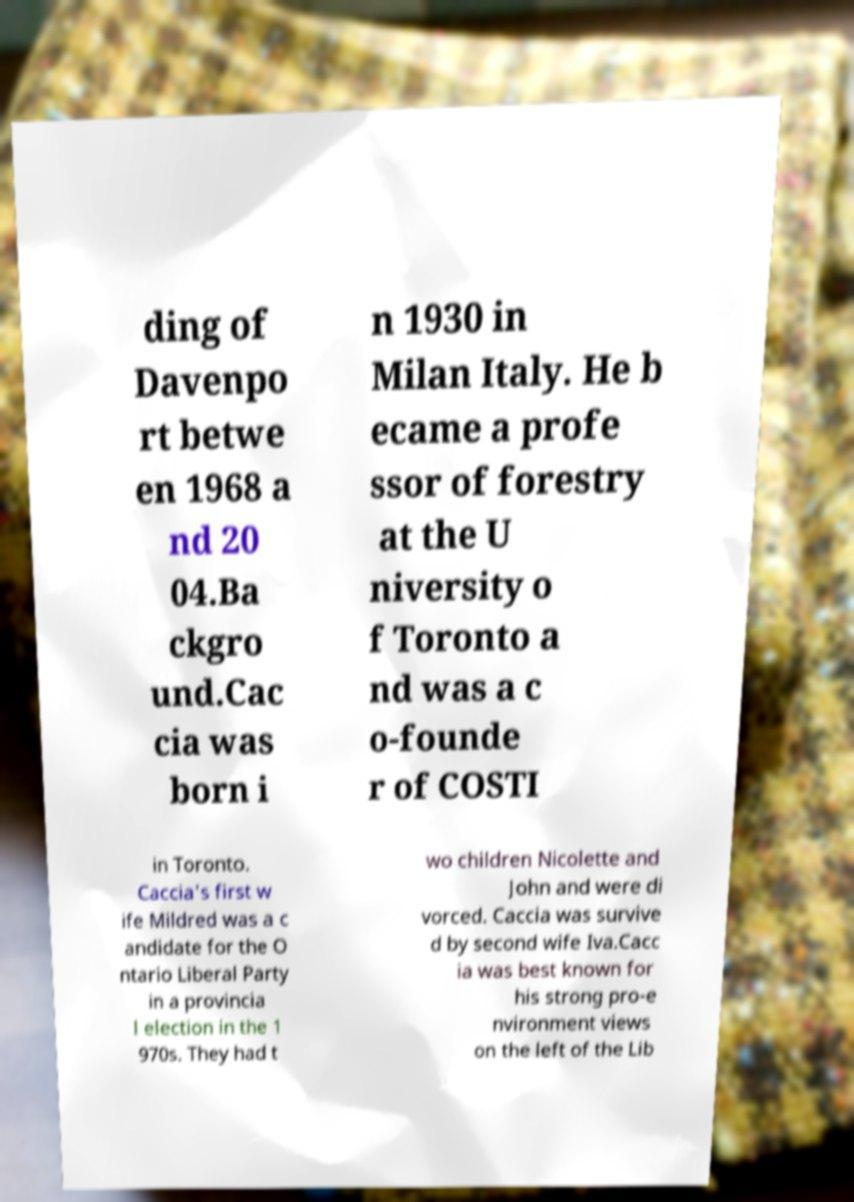I need the written content from this picture converted into text. Can you do that? ding of Davenpo rt betwe en 1968 a nd 20 04.Ba ckgro und.Cac cia was born i n 1930 in Milan Italy. He b ecame a profe ssor of forestry at the U niversity o f Toronto a nd was a c o-founde r of COSTI in Toronto. Caccia's first w ife Mildred was a c andidate for the O ntario Liberal Party in a provincia l election in the 1 970s. They had t wo children Nicolette and John and were di vorced. Caccia was survive d by second wife Iva.Cacc ia was best known for his strong pro-e nvironment views on the left of the Lib 